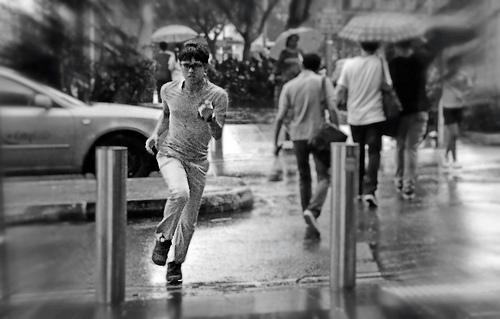Describe the image's quality based on the objects and their visibility. The image has good quality with clear visibility of objects like the umbrellas, people, car, and tree trunk. List the objects in the image and identify any object interactions. Objects: umbrellas, young man, people with umbrellas, car, glasses, shoes, tree trunk, metal poles, bags, shorts, wet ground, mobile phone, and paved sidewalk. Interactions: man running with mobile phone, people carrying bags and umbrellas. How many people are in the image and what are they doing? There are several people in the image, including a young man running, people walking with umbrellas, and a woman in dark shorts. Identify any notable objects or features near the left side of the image. Notable objects near the left side include a parked car with side view mirror, a curb on the road, and a wet road. Describe the hairstyle and clothing of the male figures in the image. All the pictured males have short, very dark hair; some wear shoulder bags, and the young man running has glasses. What is the most attention-grabbing object in the image and why? The most attention-grabbing object is the checkered design umbrella due to its large size and unique pattern. Analyze the image for any possible reasoning tasks - what can be inferred from the objects and their positions? The image suggests that the rain has recently fallen, making the ground wet, and causing people to carry umbrellas and walk cautiously. Provide a description of the central figure in the image and their actions. A young man is running in the rain while holding a mobile phone in one hand and wearing glasses. Can you count how many umbrellas are visible in the image? There are at least four umbrellas visible in the image. What kind of sentiment does this image convey? The image conveys a somewhat unfavorable sentiment due to the wet and rainy conditions. Notice the bright blue neon sign advertising a restaurant in the background. What type of cuisine does the restaurant serve? There is no mention of a bright blue neon sign or a restaurant in the image information. This instruction is not only misleading by presenting a false object, but it also asks an unrelated question to confuse the viewer further. On the right side of the image, there is a big red bus passing by. Observe its reflection on the wet ground. There is no mention of a red bus in the image information. The instruction falsely claims the presence of an object and asks the viewer to observe a specific detail that does not exist. Can you count how many bicycles are parked beside the tall tree trunk? The image information does not mention any bicycles. This instruction is misleading as it prompts the viewer to look for non-existing objects and perform an action that is not relevant to the image content. In the lower left corner of the image, you will notice a group of children playing soccer. There is no information about children playing soccer in the image. The instruction is false and misleads the viewer by drawing attention to a non-existing event in the image. The woman in the yellow raincoat is holding a baby. Can you identify her age? Neither a woman in a yellow raincoat nor a baby is mentioned. This instruction not only misleads the viewer by presenting non-existing objects but also confuses them by asking an irrelevant question. Can you find the small dog wearing a red collar next to the parked car? There is no mention of a dog or a red collar in the image information provided. The instruction is misleading as it asks the viewer to find something that does not exist in the image. 